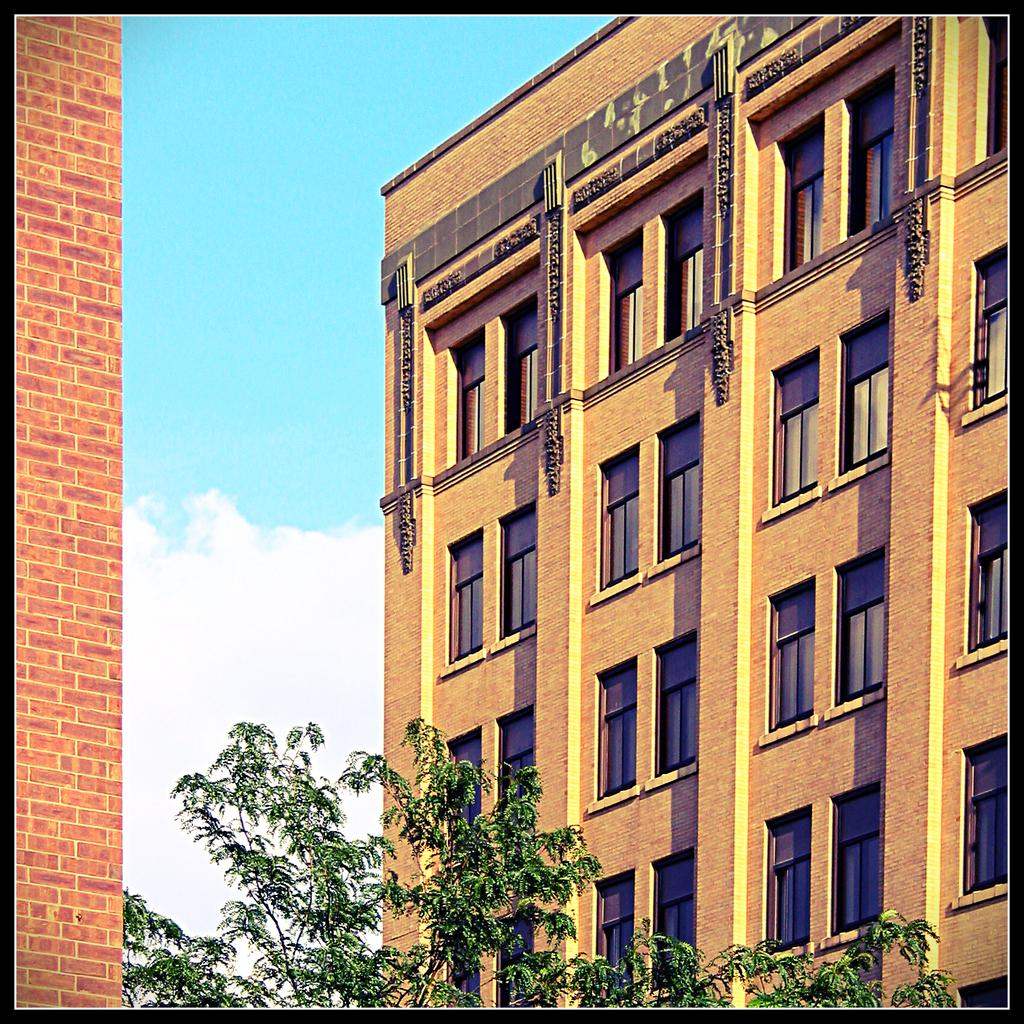What is the main subject in the middle of the picture? There is a building in the middle of the picture. What can be seen at the bottom of the picture? Trees are visible at the bottom of the picture. What is visible in the sky in the background of the picture? There are clouds in the sky in the background of the picture. What type of cheese is being used to mark the building in the picture? There is no cheese or marking visible on the building in the picture. Can you see a kitty playing among the trees at the bottom of the picture? There is no kitty present in the image; only trees are visible at the bottom. 